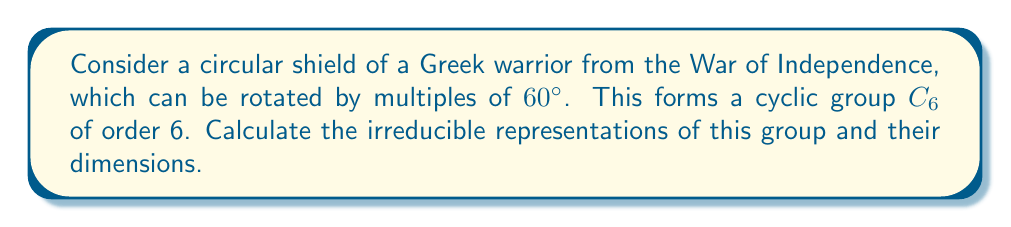Could you help me with this problem? Let's approach this step-by-step:

1) For a cyclic group $C_n$ of order $n$, there are always $n$ irreducible representations, each of dimension 1.

2) In this case, we have $C_6$, so there will be 6 irreducible representations.

3) These representations can be described as:

   $\rho_k(g) = e^{2\pi i k/6}$

   where $k = 0, 1, 2, 3, 4, 5$ and $g$ is the generator of the group (rotation by 60°).

4) Let's calculate each representation:

   $\rho_0(g) = e^{2\pi i \cdot 0/6} = 1$
   $\rho_1(g) = e^{2\pi i \cdot 1/6} = e^{\pi i/3}$
   $\rho_2(g) = e^{2\pi i \cdot 2/6} = e^{2\pi i/3}$
   $\rho_3(g) = e^{2\pi i \cdot 3/6} = e^{\pi i} = -1$
   $\rho_4(g) = e^{2\pi i \cdot 4/6} = e^{4\pi i/3}$
   $\rho_5(g) = e^{2\pi i \cdot 5/6} = e^{5\pi i/3}$

5) Each of these representations maps the generator $g$ to a complex 6th root of unity.

6) All these representations are 1-dimensional, as they map group elements to complex numbers.
Answer: 6 irreducible representations, each of dimension 1: $\rho_k(g) = e^{2\pi i k/6}$, $k = 0, 1, 2, 3, 4, 5$ 